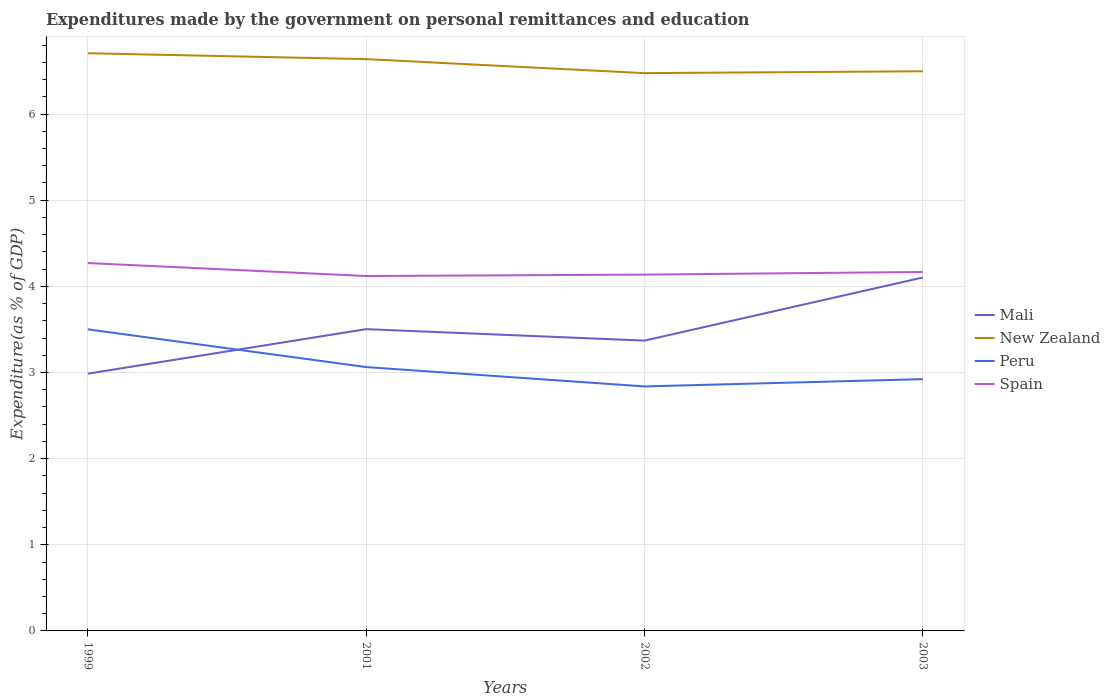How many different coloured lines are there?
Your response must be concise. 4. Does the line corresponding to Peru intersect with the line corresponding to Spain?
Keep it short and to the point. No. Across all years, what is the maximum expenditures made by the government on personal remittances and education in Spain?
Offer a terse response. 4.12. What is the total expenditures made by the government on personal remittances and education in New Zealand in the graph?
Make the answer very short. -0.02. What is the difference between the highest and the second highest expenditures made by the government on personal remittances and education in Mali?
Your response must be concise. 1.12. How many lines are there?
Make the answer very short. 4. How many years are there in the graph?
Provide a short and direct response. 4. Are the values on the major ticks of Y-axis written in scientific E-notation?
Give a very brief answer. No. Where does the legend appear in the graph?
Your answer should be very brief. Center right. What is the title of the graph?
Keep it short and to the point. Expenditures made by the government on personal remittances and education. Does "Small states" appear as one of the legend labels in the graph?
Your answer should be compact. No. What is the label or title of the Y-axis?
Your answer should be very brief. Expenditure(as % of GDP). What is the Expenditure(as % of GDP) in Mali in 1999?
Provide a short and direct response. 2.99. What is the Expenditure(as % of GDP) in New Zealand in 1999?
Provide a short and direct response. 6.71. What is the Expenditure(as % of GDP) in Peru in 1999?
Ensure brevity in your answer.  3.5. What is the Expenditure(as % of GDP) in Spain in 1999?
Your response must be concise. 4.27. What is the Expenditure(as % of GDP) in Mali in 2001?
Make the answer very short. 3.5. What is the Expenditure(as % of GDP) of New Zealand in 2001?
Offer a terse response. 6.64. What is the Expenditure(as % of GDP) in Peru in 2001?
Offer a terse response. 3.06. What is the Expenditure(as % of GDP) of Spain in 2001?
Provide a succinct answer. 4.12. What is the Expenditure(as % of GDP) of Mali in 2002?
Make the answer very short. 3.37. What is the Expenditure(as % of GDP) in New Zealand in 2002?
Provide a short and direct response. 6.48. What is the Expenditure(as % of GDP) of Peru in 2002?
Your answer should be very brief. 2.84. What is the Expenditure(as % of GDP) of Spain in 2002?
Offer a terse response. 4.14. What is the Expenditure(as % of GDP) in Mali in 2003?
Offer a very short reply. 4.1. What is the Expenditure(as % of GDP) of New Zealand in 2003?
Keep it short and to the point. 6.5. What is the Expenditure(as % of GDP) of Peru in 2003?
Your response must be concise. 2.92. What is the Expenditure(as % of GDP) of Spain in 2003?
Your answer should be very brief. 4.17. Across all years, what is the maximum Expenditure(as % of GDP) in Mali?
Your answer should be compact. 4.1. Across all years, what is the maximum Expenditure(as % of GDP) in New Zealand?
Give a very brief answer. 6.71. Across all years, what is the maximum Expenditure(as % of GDP) of Peru?
Provide a short and direct response. 3.5. Across all years, what is the maximum Expenditure(as % of GDP) of Spain?
Offer a terse response. 4.27. Across all years, what is the minimum Expenditure(as % of GDP) in Mali?
Make the answer very short. 2.99. Across all years, what is the minimum Expenditure(as % of GDP) of New Zealand?
Offer a very short reply. 6.48. Across all years, what is the minimum Expenditure(as % of GDP) in Peru?
Ensure brevity in your answer.  2.84. Across all years, what is the minimum Expenditure(as % of GDP) of Spain?
Offer a very short reply. 4.12. What is the total Expenditure(as % of GDP) in Mali in the graph?
Your answer should be very brief. 13.96. What is the total Expenditure(as % of GDP) of New Zealand in the graph?
Offer a very short reply. 26.32. What is the total Expenditure(as % of GDP) of Peru in the graph?
Offer a terse response. 12.32. What is the total Expenditure(as % of GDP) in Spain in the graph?
Give a very brief answer. 16.69. What is the difference between the Expenditure(as % of GDP) of Mali in 1999 and that in 2001?
Make the answer very short. -0.52. What is the difference between the Expenditure(as % of GDP) in New Zealand in 1999 and that in 2001?
Provide a short and direct response. 0.07. What is the difference between the Expenditure(as % of GDP) of Peru in 1999 and that in 2001?
Ensure brevity in your answer.  0.44. What is the difference between the Expenditure(as % of GDP) of Spain in 1999 and that in 2001?
Your answer should be compact. 0.15. What is the difference between the Expenditure(as % of GDP) of Mali in 1999 and that in 2002?
Your answer should be compact. -0.38. What is the difference between the Expenditure(as % of GDP) in New Zealand in 1999 and that in 2002?
Provide a short and direct response. 0.23. What is the difference between the Expenditure(as % of GDP) in Peru in 1999 and that in 2002?
Offer a very short reply. 0.66. What is the difference between the Expenditure(as % of GDP) of Spain in 1999 and that in 2002?
Keep it short and to the point. 0.13. What is the difference between the Expenditure(as % of GDP) of Mali in 1999 and that in 2003?
Your answer should be very brief. -1.12. What is the difference between the Expenditure(as % of GDP) of New Zealand in 1999 and that in 2003?
Ensure brevity in your answer.  0.21. What is the difference between the Expenditure(as % of GDP) of Peru in 1999 and that in 2003?
Your answer should be compact. 0.58. What is the difference between the Expenditure(as % of GDP) of Spain in 1999 and that in 2003?
Your answer should be very brief. 0.1. What is the difference between the Expenditure(as % of GDP) of Mali in 2001 and that in 2002?
Make the answer very short. 0.13. What is the difference between the Expenditure(as % of GDP) in New Zealand in 2001 and that in 2002?
Your response must be concise. 0.16. What is the difference between the Expenditure(as % of GDP) in Peru in 2001 and that in 2002?
Your answer should be very brief. 0.22. What is the difference between the Expenditure(as % of GDP) in Spain in 2001 and that in 2002?
Make the answer very short. -0.02. What is the difference between the Expenditure(as % of GDP) of New Zealand in 2001 and that in 2003?
Provide a short and direct response. 0.14. What is the difference between the Expenditure(as % of GDP) in Peru in 2001 and that in 2003?
Offer a terse response. 0.14. What is the difference between the Expenditure(as % of GDP) of Spain in 2001 and that in 2003?
Your answer should be compact. -0.05. What is the difference between the Expenditure(as % of GDP) in Mali in 2002 and that in 2003?
Offer a very short reply. -0.73. What is the difference between the Expenditure(as % of GDP) in New Zealand in 2002 and that in 2003?
Your response must be concise. -0.02. What is the difference between the Expenditure(as % of GDP) in Peru in 2002 and that in 2003?
Ensure brevity in your answer.  -0.08. What is the difference between the Expenditure(as % of GDP) in Spain in 2002 and that in 2003?
Offer a terse response. -0.03. What is the difference between the Expenditure(as % of GDP) in Mali in 1999 and the Expenditure(as % of GDP) in New Zealand in 2001?
Your answer should be compact. -3.65. What is the difference between the Expenditure(as % of GDP) in Mali in 1999 and the Expenditure(as % of GDP) in Peru in 2001?
Offer a very short reply. -0.08. What is the difference between the Expenditure(as % of GDP) of Mali in 1999 and the Expenditure(as % of GDP) of Spain in 2001?
Keep it short and to the point. -1.13. What is the difference between the Expenditure(as % of GDP) of New Zealand in 1999 and the Expenditure(as % of GDP) of Peru in 2001?
Your response must be concise. 3.64. What is the difference between the Expenditure(as % of GDP) of New Zealand in 1999 and the Expenditure(as % of GDP) of Spain in 2001?
Keep it short and to the point. 2.59. What is the difference between the Expenditure(as % of GDP) of Peru in 1999 and the Expenditure(as % of GDP) of Spain in 2001?
Ensure brevity in your answer.  -0.62. What is the difference between the Expenditure(as % of GDP) in Mali in 1999 and the Expenditure(as % of GDP) in New Zealand in 2002?
Keep it short and to the point. -3.49. What is the difference between the Expenditure(as % of GDP) of Mali in 1999 and the Expenditure(as % of GDP) of Peru in 2002?
Offer a terse response. 0.15. What is the difference between the Expenditure(as % of GDP) of Mali in 1999 and the Expenditure(as % of GDP) of Spain in 2002?
Provide a short and direct response. -1.15. What is the difference between the Expenditure(as % of GDP) in New Zealand in 1999 and the Expenditure(as % of GDP) in Peru in 2002?
Your answer should be compact. 3.87. What is the difference between the Expenditure(as % of GDP) of New Zealand in 1999 and the Expenditure(as % of GDP) of Spain in 2002?
Provide a short and direct response. 2.57. What is the difference between the Expenditure(as % of GDP) in Peru in 1999 and the Expenditure(as % of GDP) in Spain in 2002?
Provide a short and direct response. -0.64. What is the difference between the Expenditure(as % of GDP) in Mali in 1999 and the Expenditure(as % of GDP) in New Zealand in 2003?
Offer a terse response. -3.51. What is the difference between the Expenditure(as % of GDP) of Mali in 1999 and the Expenditure(as % of GDP) of Peru in 2003?
Offer a very short reply. 0.06. What is the difference between the Expenditure(as % of GDP) of Mali in 1999 and the Expenditure(as % of GDP) of Spain in 2003?
Offer a very short reply. -1.18. What is the difference between the Expenditure(as % of GDP) in New Zealand in 1999 and the Expenditure(as % of GDP) in Peru in 2003?
Provide a succinct answer. 3.78. What is the difference between the Expenditure(as % of GDP) of New Zealand in 1999 and the Expenditure(as % of GDP) of Spain in 2003?
Your response must be concise. 2.54. What is the difference between the Expenditure(as % of GDP) in Peru in 1999 and the Expenditure(as % of GDP) in Spain in 2003?
Provide a short and direct response. -0.67. What is the difference between the Expenditure(as % of GDP) in Mali in 2001 and the Expenditure(as % of GDP) in New Zealand in 2002?
Make the answer very short. -2.97. What is the difference between the Expenditure(as % of GDP) of Mali in 2001 and the Expenditure(as % of GDP) of Peru in 2002?
Offer a terse response. 0.66. What is the difference between the Expenditure(as % of GDP) of Mali in 2001 and the Expenditure(as % of GDP) of Spain in 2002?
Your answer should be compact. -0.63. What is the difference between the Expenditure(as % of GDP) of New Zealand in 2001 and the Expenditure(as % of GDP) of Peru in 2002?
Make the answer very short. 3.8. What is the difference between the Expenditure(as % of GDP) in New Zealand in 2001 and the Expenditure(as % of GDP) in Spain in 2002?
Provide a succinct answer. 2.5. What is the difference between the Expenditure(as % of GDP) in Peru in 2001 and the Expenditure(as % of GDP) in Spain in 2002?
Make the answer very short. -1.07. What is the difference between the Expenditure(as % of GDP) in Mali in 2001 and the Expenditure(as % of GDP) in New Zealand in 2003?
Provide a succinct answer. -2.99. What is the difference between the Expenditure(as % of GDP) in Mali in 2001 and the Expenditure(as % of GDP) in Peru in 2003?
Provide a short and direct response. 0.58. What is the difference between the Expenditure(as % of GDP) in Mali in 2001 and the Expenditure(as % of GDP) in Spain in 2003?
Keep it short and to the point. -0.66. What is the difference between the Expenditure(as % of GDP) of New Zealand in 2001 and the Expenditure(as % of GDP) of Peru in 2003?
Keep it short and to the point. 3.71. What is the difference between the Expenditure(as % of GDP) of New Zealand in 2001 and the Expenditure(as % of GDP) of Spain in 2003?
Ensure brevity in your answer.  2.47. What is the difference between the Expenditure(as % of GDP) of Peru in 2001 and the Expenditure(as % of GDP) of Spain in 2003?
Give a very brief answer. -1.1. What is the difference between the Expenditure(as % of GDP) in Mali in 2002 and the Expenditure(as % of GDP) in New Zealand in 2003?
Offer a very short reply. -3.13. What is the difference between the Expenditure(as % of GDP) of Mali in 2002 and the Expenditure(as % of GDP) of Peru in 2003?
Keep it short and to the point. 0.45. What is the difference between the Expenditure(as % of GDP) of Mali in 2002 and the Expenditure(as % of GDP) of Spain in 2003?
Keep it short and to the point. -0.8. What is the difference between the Expenditure(as % of GDP) of New Zealand in 2002 and the Expenditure(as % of GDP) of Peru in 2003?
Your answer should be compact. 3.55. What is the difference between the Expenditure(as % of GDP) of New Zealand in 2002 and the Expenditure(as % of GDP) of Spain in 2003?
Provide a succinct answer. 2.31. What is the difference between the Expenditure(as % of GDP) of Peru in 2002 and the Expenditure(as % of GDP) of Spain in 2003?
Provide a short and direct response. -1.33. What is the average Expenditure(as % of GDP) in Mali per year?
Your answer should be compact. 3.49. What is the average Expenditure(as % of GDP) of New Zealand per year?
Offer a terse response. 6.58. What is the average Expenditure(as % of GDP) of Peru per year?
Provide a short and direct response. 3.08. What is the average Expenditure(as % of GDP) of Spain per year?
Provide a short and direct response. 4.17. In the year 1999, what is the difference between the Expenditure(as % of GDP) in Mali and Expenditure(as % of GDP) in New Zealand?
Make the answer very short. -3.72. In the year 1999, what is the difference between the Expenditure(as % of GDP) in Mali and Expenditure(as % of GDP) in Peru?
Give a very brief answer. -0.51. In the year 1999, what is the difference between the Expenditure(as % of GDP) in Mali and Expenditure(as % of GDP) in Spain?
Your answer should be compact. -1.28. In the year 1999, what is the difference between the Expenditure(as % of GDP) of New Zealand and Expenditure(as % of GDP) of Peru?
Provide a short and direct response. 3.21. In the year 1999, what is the difference between the Expenditure(as % of GDP) in New Zealand and Expenditure(as % of GDP) in Spain?
Your answer should be compact. 2.44. In the year 1999, what is the difference between the Expenditure(as % of GDP) in Peru and Expenditure(as % of GDP) in Spain?
Provide a short and direct response. -0.77. In the year 2001, what is the difference between the Expenditure(as % of GDP) in Mali and Expenditure(as % of GDP) in New Zealand?
Offer a very short reply. -3.13. In the year 2001, what is the difference between the Expenditure(as % of GDP) in Mali and Expenditure(as % of GDP) in Peru?
Make the answer very short. 0.44. In the year 2001, what is the difference between the Expenditure(as % of GDP) in Mali and Expenditure(as % of GDP) in Spain?
Your response must be concise. -0.62. In the year 2001, what is the difference between the Expenditure(as % of GDP) in New Zealand and Expenditure(as % of GDP) in Peru?
Your response must be concise. 3.57. In the year 2001, what is the difference between the Expenditure(as % of GDP) in New Zealand and Expenditure(as % of GDP) in Spain?
Make the answer very short. 2.52. In the year 2001, what is the difference between the Expenditure(as % of GDP) in Peru and Expenditure(as % of GDP) in Spain?
Offer a terse response. -1.06. In the year 2002, what is the difference between the Expenditure(as % of GDP) in Mali and Expenditure(as % of GDP) in New Zealand?
Your answer should be compact. -3.1. In the year 2002, what is the difference between the Expenditure(as % of GDP) of Mali and Expenditure(as % of GDP) of Peru?
Ensure brevity in your answer.  0.53. In the year 2002, what is the difference between the Expenditure(as % of GDP) in Mali and Expenditure(as % of GDP) in Spain?
Make the answer very short. -0.77. In the year 2002, what is the difference between the Expenditure(as % of GDP) of New Zealand and Expenditure(as % of GDP) of Peru?
Provide a succinct answer. 3.64. In the year 2002, what is the difference between the Expenditure(as % of GDP) in New Zealand and Expenditure(as % of GDP) in Spain?
Ensure brevity in your answer.  2.34. In the year 2002, what is the difference between the Expenditure(as % of GDP) in Peru and Expenditure(as % of GDP) in Spain?
Make the answer very short. -1.3. In the year 2003, what is the difference between the Expenditure(as % of GDP) of Mali and Expenditure(as % of GDP) of New Zealand?
Give a very brief answer. -2.39. In the year 2003, what is the difference between the Expenditure(as % of GDP) in Mali and Expenditure(as % of GDP) in Peru?
Your answer should be compact. 1.18. In the year 2003, what is the difference between the Expenditure(as % of GDP) of Mali and Expenditure(as % of GDP) of Spain?
Your response must be concise. -0.06. In the year 2003, what is the difference between the Expenditure(as % of GDP) in New Zealand and Expenditure(as % of GDP) in Peru?
Provide a short and direct response. 3.57. In the year 2003, what is the difference between the Expenditure(as % of GDP) of New Zealand and Expenditure(as % of GDP) of Spain?
Provide a short and direct response. 2.33. In the year 2003, what is the difference between the Expenditure(as % of GDP) in Peru and Expenditure(as % of GDP) in Spain?
Ensure brevity in your answer.  -1.24. What is the ratio of the Expenditure(as % of GDP) of Mali in 1999 to that in 2001?
Ensure brevity in your answer.  0.85. What is the ratio of the Expenditure(as % of GDP) of New Zealand in 1999 to that in 2001?
Give a very brief answer. 1.01. What is the ratio of the Expenditure(as % of GDP) in Peru in 1999 to that in 2001?
Offer a very short reply. 1.14. What is the ratio of the Expenditure(as % of GDP) of Spain in 1999 to that in 2001?
Provide a short and direct response. 1.04. What is the ratio of the Expenditure(as % of GDP) of Mali in 1999 to that in 2002?
Provide a succinct answer. 0.89. What is the ratio of the Expenditure(as % of GDP) of New Zealand in 1999 to that in 2002?
Ensure brevity in your answer.  1.04. What is the ratio of the Expenditure(as % of GDP) of Peru in 1999 to that in 2002?
Offer a very short reply. 1.23. What is the ratio of the Expenditure(as % of GDP) of Spain in 1999 to that in 2002?
Give a very brief answer. 1.03. What is the ratio of the Expenditure(as % of GDP) of Mali in 1999 to that in 2003?
Ensure brevity in your answer.  0.73. What is the ratio of the Expenditure(as % of GDP) in New Zealand in 1999 to that in 2003?
Your answer should be compact. 1.03. What is the ratio of the Expenditure(as % of GDP) of Peru in 1999 to that in 2003?
Give a very brief answer. 1.2. What is the ratio of the Expenditure(as % of GDP) of Spain in 1999 to that in 2003?
Your answer should be compact. 1.02. What is the ratio of the Expenditure(as % of GDP) of Mali in 2001 to that in 2002?
Your answer should be compact. 1.04. What is the ratio of the Expenditure(as % of GDP) of New Zealand in 2001 to that in 2002?
Provide a succinct answer. 1.03. What is the ratio of the Expenditure(as % of GDP) in Peru in 2001 to that in 2002?
Your answer should be very brief. 1.08. What is the ratio of the Expenditure(as % of GDP) in Spain in 2001 to that in 2002?
Keep it short and to the point. 1. What is the ratio of the Expenditure(as % of GDP) of Mali in 2001 to that in 2003?
Your answer should be very brief. 0.85. What is the ratio of the Expenditure(as % of GDP) of New Zealand in 2001 to that in 2003?
Provide a succinct answer. 1.02. What is the ratio of the Expenditure(as % of GDP) of Peru in 2001 to that in 2003?
Offer a terse response. 1.05. What is the ratio of the Expenditure(as % of GDP) of Spain in 2001 to that in 2003?
Keep it short and to the point. 0.99. What is the ratio of the Expenditure(as % of GDP) in Mali in 2002 to that in 2003?
Offer a terse response. 0.82. What is the ratio of the Expenditure(as % of GDP) in Peru in 2002 to that in 2003?
Keep it short and to the point. 0.97. What is the ratio of the Expenditure(as % of GDP) in Spain in 2002 to that in 2003?
Make the answer very short. 0.99. What is the difference between the highest and the second highest Expenditure(as % of GDP) of Mali?
Ensure brevity in your answer.  0.6. What is the difference between the highest and the second highest Expenditure(as % of GDP) of New Zealand?
Make the answer very short. 0.07. What is the difference between the highest and the second highest Expenditure(as % of GDP) in Peru?
Your answer should be compact. 0.44. What is the difference between the highest and the second highest Expenditure(as % of GDP) in Spain?
Your response must be concise. 0.1. What is the difference between the highest and the lowest Expenditure(as % of GDP) of Mali?
Give a very brief answer. 1.12. What is the difference between the highest and the lowest Expenditure(as % of GDP) of New Zealand?
Offer a very short reply. 0.23. What is the difference between the highest and the lowest Expenditure(as % of GDP) in Peru?
Offer a terse response. 0.66. What is the difference between the highest and the lowest Expenditure(as % of GDP) of Spain?
Give a very brief answer. 0.15. 